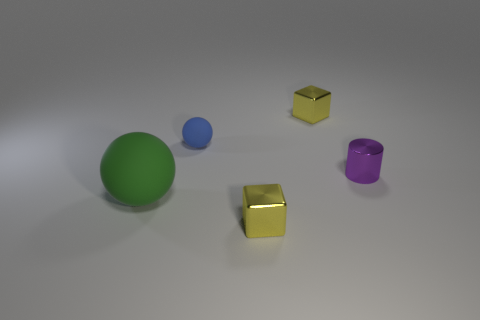Is there anything else that is the same size as the green ball?
Provide a succinct answer. No. What material is the large sphere?
Your answer should be very brief. Rubber. The sphere that is the same size as the purple metal object is what color?
Keep it short and to the point. Blue. Is the large matte thing the same shape as the small rubber object?
Offer a very short reply. Yes. What is the material of the tiny object that is behind the metal cylinder and right of the blue ball?
Ensure brevity in your answer.  Metal. The blue matte object is what size?
Your answer should be very brief. Small. What color is the other rubber object that is the same shape as the blue matte object?
Make the answer very short. Green. Are there any other things of the same color as the small sphere?
Your answer should be very brief. No. There is a metal thing that is in front of the purple shiny cylinder; is its size the same as the matte thing that is in front of the tiny blue object?
Make the answer very short. No. Is the number of blue matte objects that are in front of the purple metallic object the same as the number of green things that are behind the blue thing?
Your answer should be compact. Yes. 